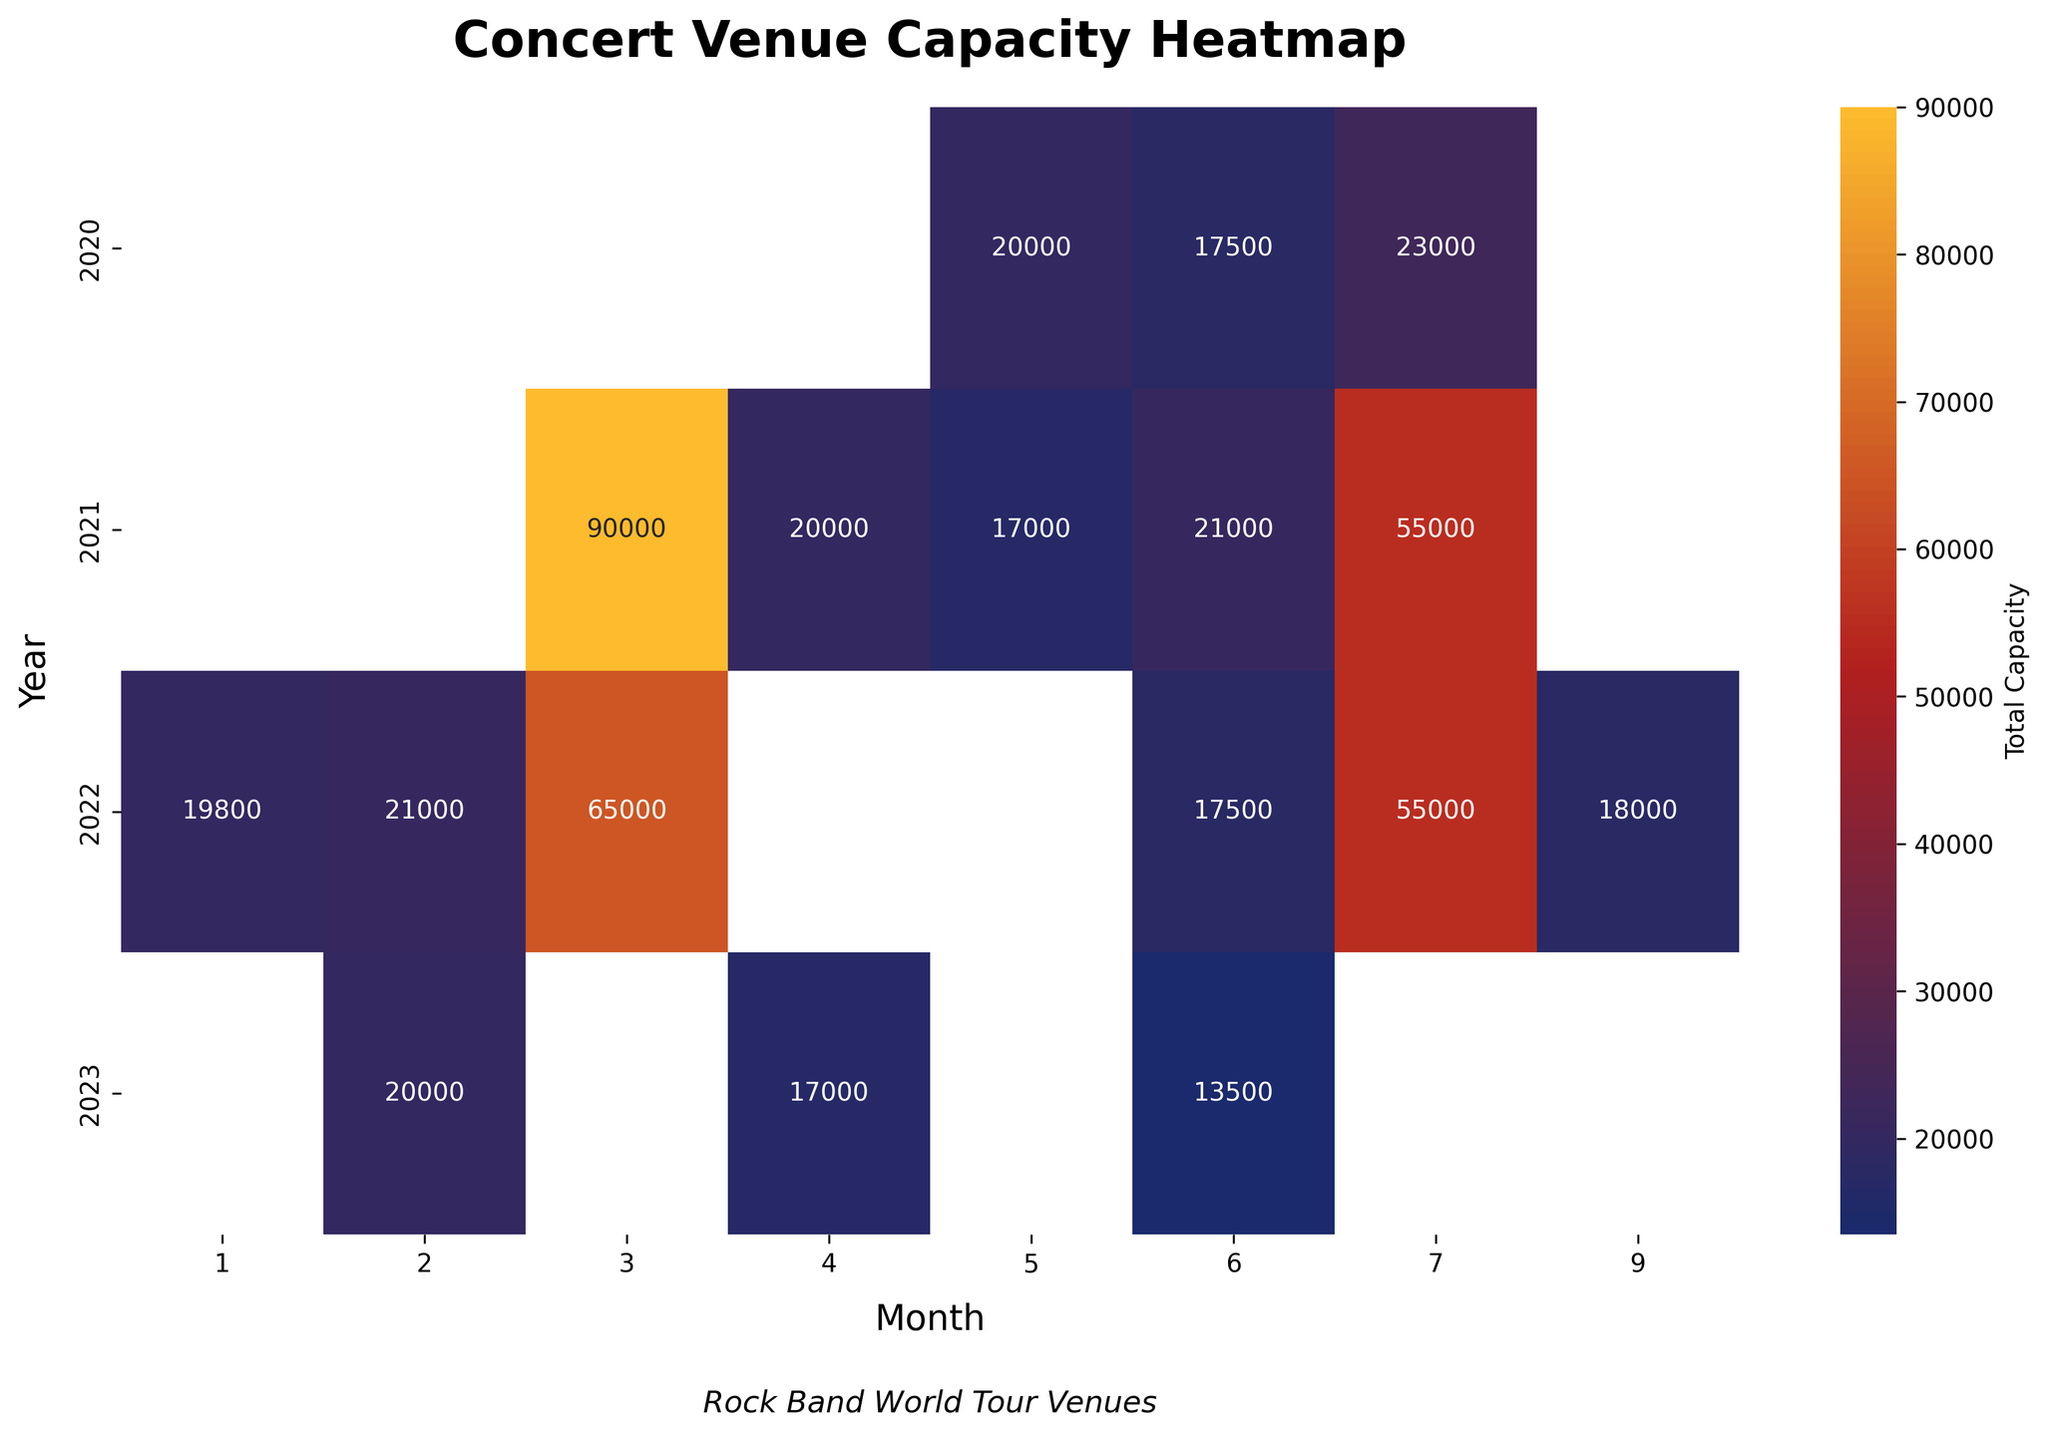What is the highest venue capacity in 2021? To find the highest venue capacity in 2021, look at the data from the heatmap specifically for the year 2021. Identify the highest value in that row.
Answer: 90,000 What year and month had the lowest venue capacity, and what was it? Scan the heatmap for the smallest value among all cells. Then identify the row (year) and column (month) where this value is located.
Answer: 2023, June, 13,500 How does the total capacity in July 2022 compare to July 2021? Locate the cell for July 2022 and July 2021. Compare the two values directly by subtraction.
Answer: 55,000 - 55,000 = 0 What's the trend in venue capacity from January to June 2022? Examine the cells from January to June 2022. Observe if values are going up or down and summarize the pattern.
Answer: Increasing Which month in 2022 had the highest total venue capacity? Check the cells in 2022 row for each month. Identify the month with the highest value.
Answer: March What is the average venue capacity for all concerts held in June over the years? Find all the values in June for every year on the heatmap. Sum them up and then divide by the number of years (months), which is 3 in this case.
Answer: (17,500 + 21,000 + 13,500) / 3 = 17,333 